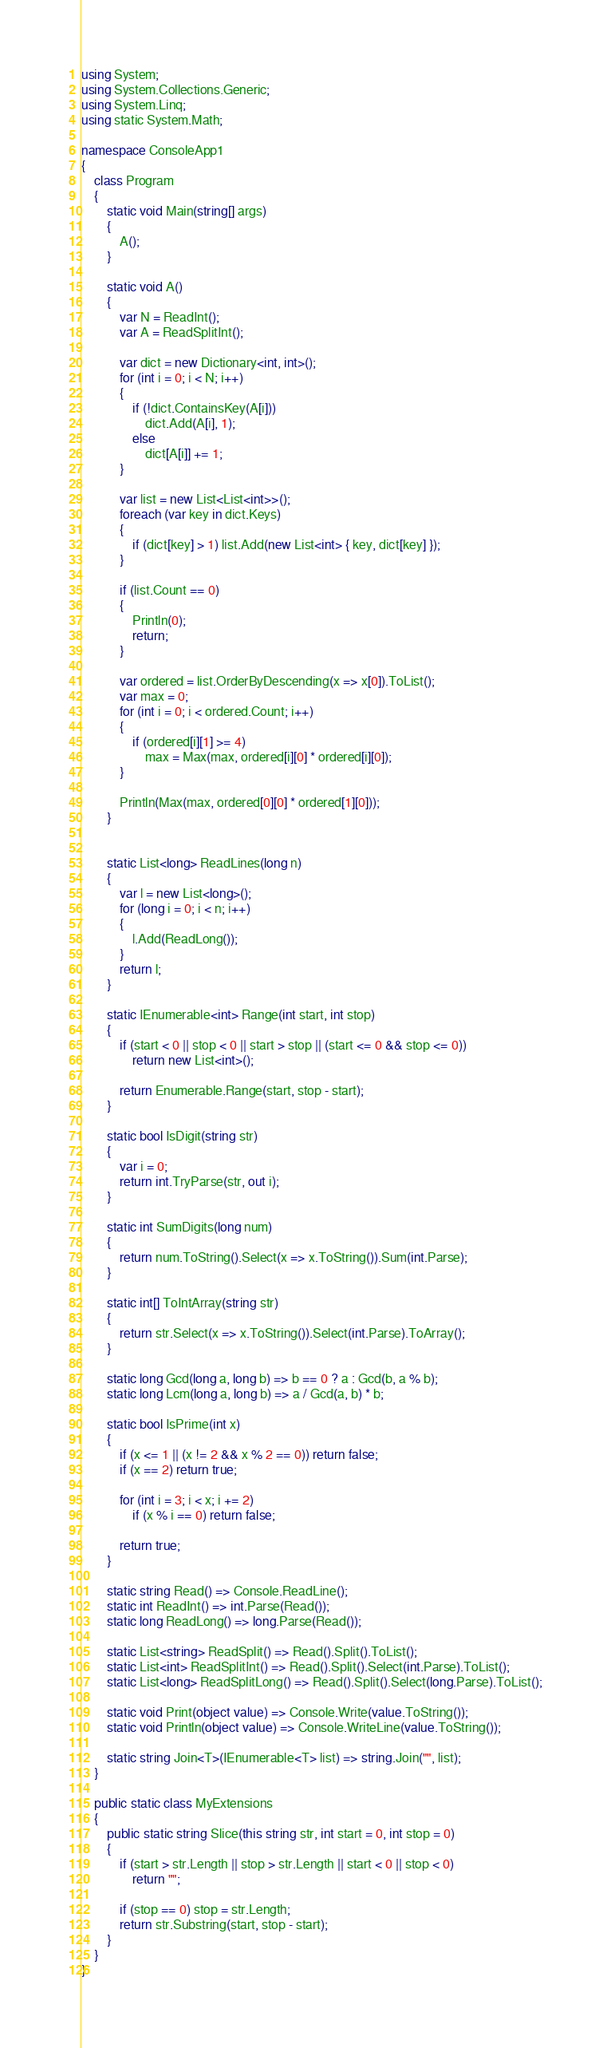Convert code to text. <code><loc_0><loc_0><loc_500><loc_500><_C#_>using System;
using System.Collections.Generic;
using System.Linq;
using static System.Math;

namespace ConsoleApp1
{
    class Program
    {
        static void Main(string[] args)
        {
            A();
        }

        static void A()
        {
            var N = ReadInt();
            var A = ReadSplitInt();

            var dict = new Dictionary<int, int>();
            for (int i = 0; i < N; i++)
            {
                if (!dict.ContainsKey(A[i]))
                    dict.Add(A[i], 1);
                else
                    dict[A[i]] += 1;
            }

            var list = new List<List<int>>();
            foreach (var key in dict.Keys)
            {
                if (dict[key] > 1) list.Add(new List<int> { key, dict[key] });
            }

            if (list.Count == 0)
            {
                Println(0);
                return;
            }

            var ordered = list.OrderByDescending(x => x[0]).ToList();
            var max = 0;
            for (int i = 0; i < ordered.Count; i++)
            {
                if (ordered[i][1] >= 4)
                    max = Max(max, ordered[i][0] * ordered[i][0]);
            }

            Println(Max(max, ordered[0][0] * ordered[1][0]));
        }


        static List<long> ReadLines(long n)
        {
            var l = new List<long>();
            for (long i = 0; i < n; i++)
            {
                l.Add(ReadLong());
            }
            return l;
        }

        static IEnumerable<int> Range(int start, int stop)
        {
            if (start < 0 || stop < 0 || start > stop || (start <= 0 && stop <= 0))
                return new List<int>();

            return Enumerable.Range(start, stop - start);
        }

        static bool IsDigit(string str)
        {
            var i = 0;
            return int.TryParse(str, out i);
        }

        static int SumDigits(long num)
        {
            return num.ToString().Select(x => x.ToString()).Sum(int.Parse);
        }

        static int[] ToIntArray(string str)
        {
            return str.Select(x => x.ToString()).Select(int.Parse).ToArray();
        }

        static long Gcd(long a, long b) => b == 0 ? a : Gcd(b, a % b);
        static long Lcm(long a, long b) => a / Gcd(a, b) * b;

        static bool IsPrime(int x)
        {
            if (x <= 1 || (x != 2 && x % 2 == 0)) return false;
            if (x == 2) return true;

            for (int i = 3; i < x; i += 2)
                if (x % i == 0) return false;

            return true;
        }

        static string Read() => Console.ReadLine();
        static int ReadInt() => int.Parse(Read());
        static long ReadLong() => long.Parse(Read());

        static List<string> ReadSplit() => Read().Split().ToList();
        static List<int> ReadSplitInt() => Read().Split().Select(int.Parse).ToList();
        static List<long> ReadSplitLong() => Read().Split().Select(long.Parse).ToList();

        static void Print(object value) => Console.Write(value.ToString());
        static void Println(object value) => Console.WriteLine(value.ToString());

        static string Join<T>(IEnumerable<T> list) => string.Join("", list);
    }

    public static class MyExtensions
    {
        public static string Slice(this string str, int start = 0, int stop = 0)
        {
            if (start > str.Length || stop > str.Length || start < 0 || stop < 0)
                return "";

            if (stop == 0) stop = str.Length;
            return str.Substring(start, stop - start);
        }
    }
}
</code> 